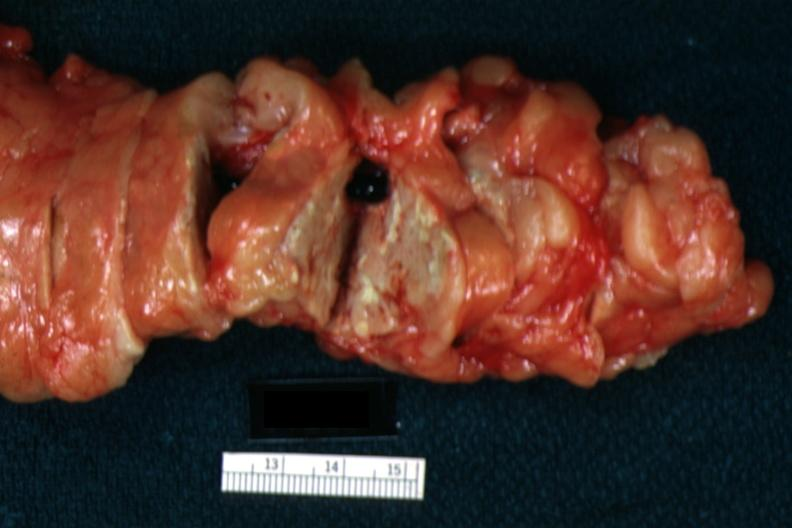s adenoma sebaceum present?
Answer the question using a single word or phrase. No 